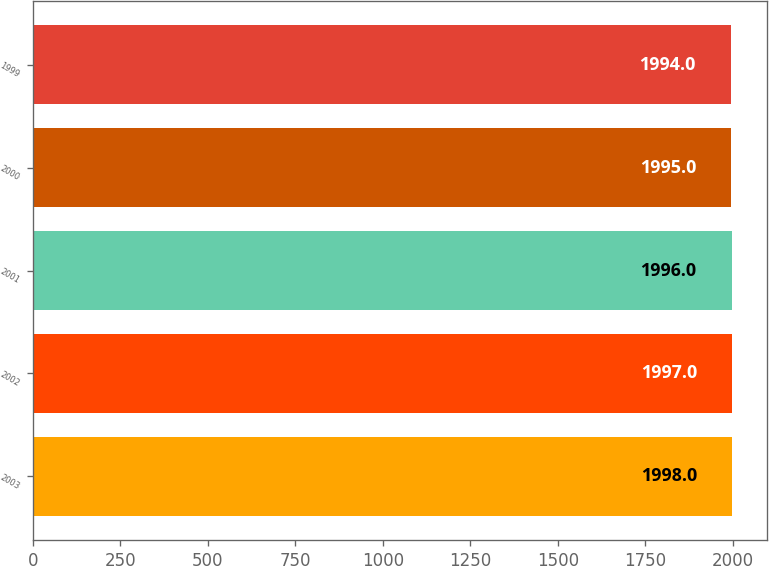Convert chart to OTSL. <chart><loc_0><loc_0><loc_500><loc_500><bar_chart><fcel>2003<fcel>2002<fcel>2001<fcel>2000<fcel>1999<nl><fcel>1998<fcel>1997<fcel>1996<fcel>1995<fcel>1994<nl></chart> 